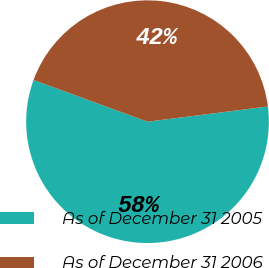<chart> <loc_0><loc_0><loc_500><loc_500><pie_chart><fcel>As of December 31 2005<fcel>As of December 31 2006<nl><fcel>57.58%<fcel>42.42%<nl></chart> 